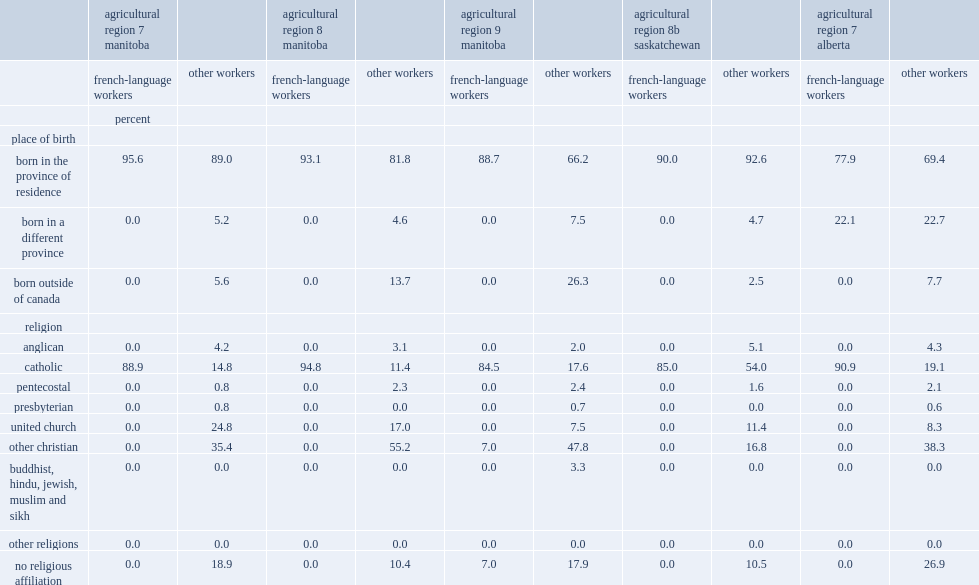In alberta's agricultural region 7, what was the percentage of french-language workers born in canada, but in a province other than alberta? 22.1. In 2011, what was the percentage of french-language agricultural workers were catholic, significantly higher than for other agricultural workers in the region? 88.9. What was the percentage of french-language workers declared having no religious affiliation of french-language workers in manitoba's region 9? 7.0. What was the percentage of the other agricultural workers declared having no religious affiliation in manitoba's region 9? 17.9. 